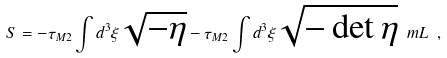Convert formula to latex. <formula><loc_0><loc_0><loc_500><loc_500>S = - \tau _ { M 2 } \int d ^ { 3 } \xi \sqrt { - \eta } - \tau _ { M 2 } \int d ^ { 3 } \xi \sqrt { - \det \eta } \ m L \ ,</formula> 